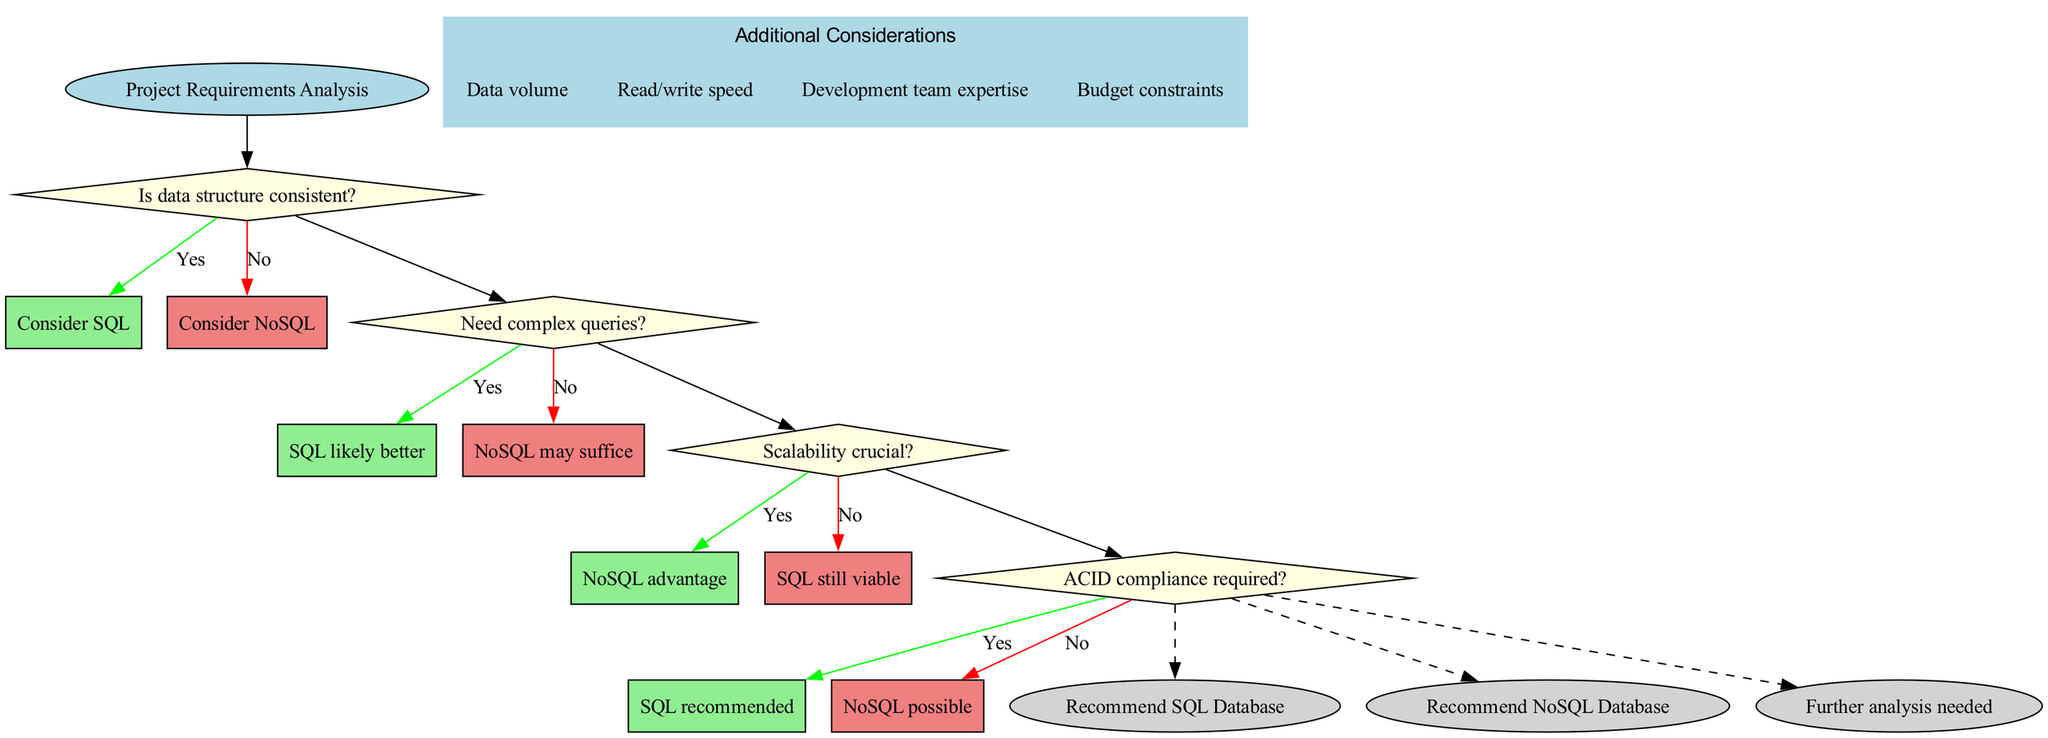What is the start node of the flowchart? The flowchart begins with the node labeled 'Project Requirements Analysis', which indicates the initial action or consideration to be made in the decision-making process.
Answer: Project Requirements Analysis How many decision nodes are present in the diagram? There are four decision nodes in the flowchart, each representing a critical question that guides the decision between SQL and NoSQL databases.
Answer: 4 What happens if the answer to "Is data structure consistent?" is yes? If the response is 'Yes', the flowchart suggests considering SQL as a potential choice for the database, indicating that a consistent data structure aligns with SQL's strengths.
Answer: Consider SQL What is the recommendation if all decisions favor NoSQL? If the flowchart indicates that NoSQL is the favored option in all decision paths, the endpoint reached would be 'Recommend NoSQL Database', as it aligns with the last decision's conclusion.
Answer: Recommend NoSQL Database In which scenario is SQL recommended according to the flowchart? SQL is recommended when the answers to both "Is data structure consistent?" and "ACID compliance required?" are 'Yes', suggesting that SQL databases are well-suited for projects requiring these features.
Answer: SQL recommended If scalability is crucial, what is the next step based on the diagram? If scalability is deemed crucial ('Yes' for the question about scalability), the flowchart directs attention toward NoSQL as the advantageous choice for handling large volumes of data efficiently.
Answer: NoSQL advantage What additional considerations are mentioned in the diagram? The flowchart lists four additional considerations, including Data volume, Read/write speed, Development team expertise, and Budget constraints as factors to evaluate in the decision-making process.
Answer: Data volume, Read/write speed, Development team expertise, Budget constraints What will the outcome be if the project requires complex queries and scalability is not crucial? If complex queries are needed but scalability is not a significant factor, the flowchart suggests that SQL is likely to be the better option, despite concerns around scalability, indicating SQL's strengths in handling complex queries.
Answer: SQL likely better What color represents the decision nodes in the flowchart? The decision nodes are represented in light yellow, helping to visually distinguish them from other node types like the start and endpoint nodes.
Answer: Light yellow 